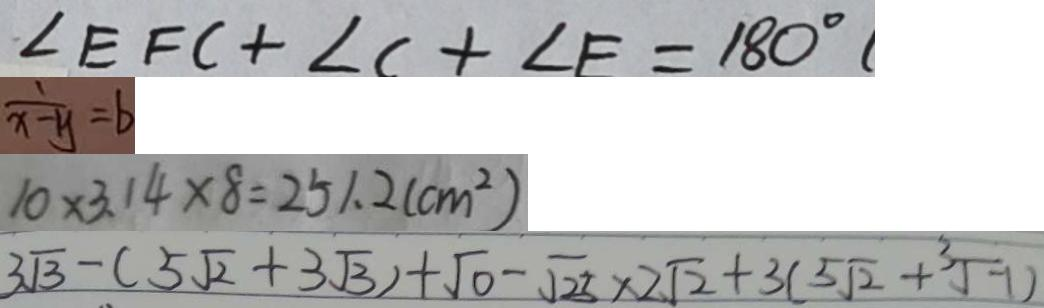<formula> <loc_0><loc_0><loc_500><loc_500>\angle E F C + \angle C + \angle E = 1 8 0 ^ { \circ } 
 \frac { 1 } { x - y } = b 
 1 0 \times 3 . 1 4 \times 8 = 2 5 1 . 2 ( c m ^ { 2 } ) 
 3 \sqrt { 3 } - ( 5 \sqrt { 2 } + 3 \sqrt { 3 } ) + \sqrt { 0 } - \sqrt { 2 5 } \times 2 \sqrt { 2 } + 3 ( 5 \sqrt { 2 } + \sqrt [ 3 ] { - 1 } )</formula> 